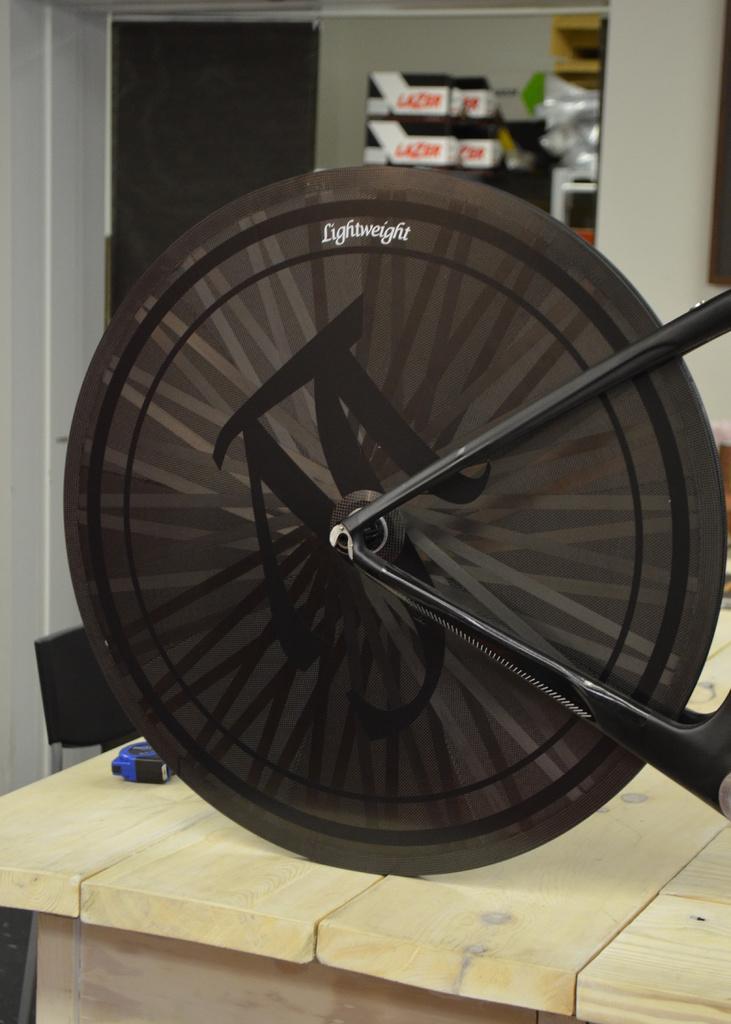Please provide a concise description of this image. A picture of a cycle wheel. Beside this cycle wheel there is a table and chair. Far there are things in a rack. 